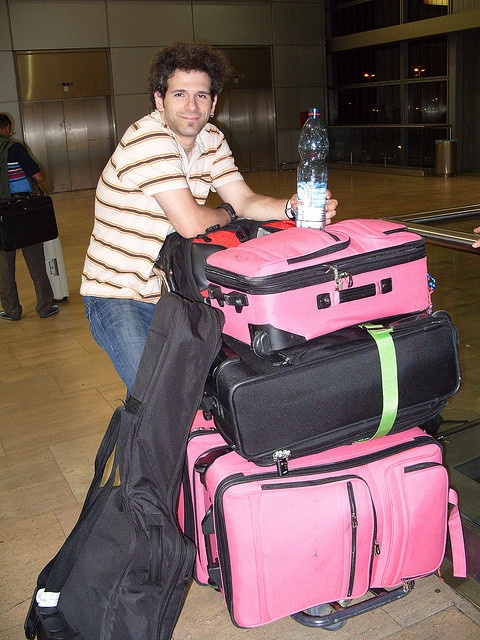Describe the objects in this image and their specific colors. I can see suitcase in black, lightpink, and pink tones, people in black, white, and tan tones, suitcase in black and gray tones, suitcase in black, lightpink, and gray tones, and people in black, olive, maroon, and blue tones in this image. 